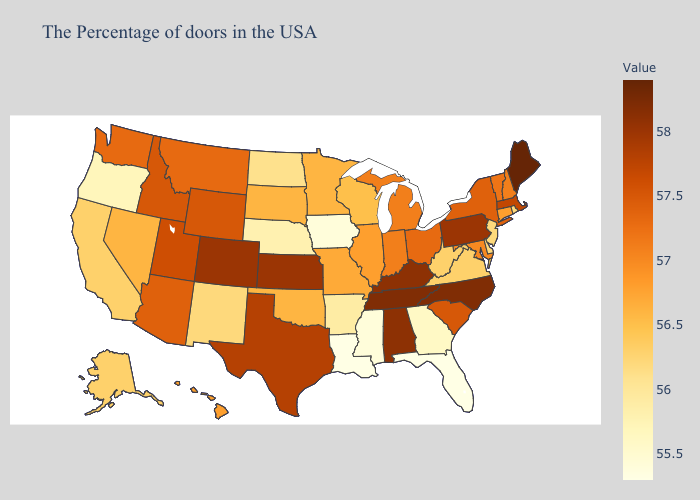Does Maine have the highest value in the USA?
Short answer required. Yes. Does South Dakota have the lowest value in the MidWest?
Keep it brief. No. Among the states that border Idaho , does Utah have the highest value?
Short answer required. Yes. Which states have the lowest value in the USA?
Give a very brief answer. Florida, Louisiana. Which states hav the highest value in the West?
Answer briefly. Colorado. Which states hav the highest value in the Northeast?
Be succinct. Maine. Does Missouri have a higher value than Pennsylvania?
Keep it brief. No. 